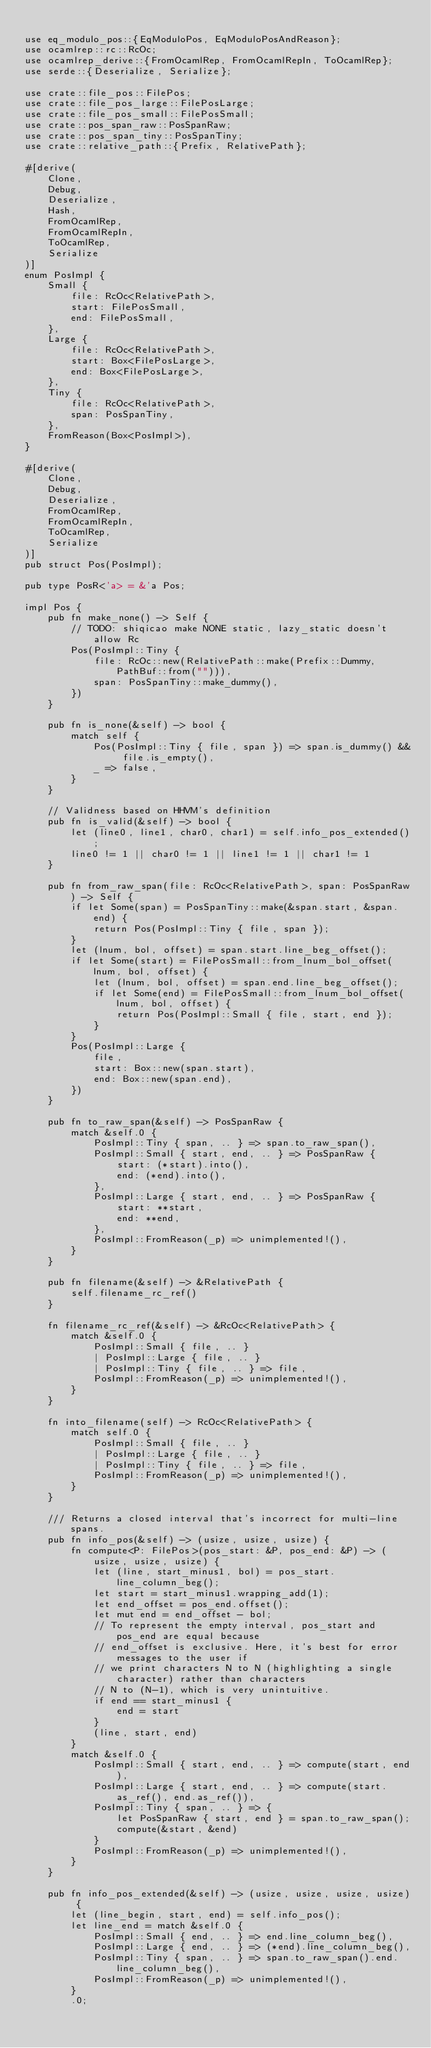<code> <loc_0><loc_0><loc_500><loc_500><_Rust_>
use eq_modulo_pos::{EqModuloPos, EqModuloPosAndReason};
use ocamlrep::rc::RcOc;
use ocamlrep_derive::{FromOcamlRep, FromOcamlRepIn, ToOcamlRep};
use serde::{Deserialize, Serialize};

use crate::file_pos::FilePos;
use crate::file_pos_large::FilePosLarge;
use crate::file_pos_small::FilePosSmall;
use crate::pos_span_raw::PosSpanRaw;
use crate::pos_span_tiny::PosSpanTiny;
use crate::relative_path::{Prefix, RelativePath};

#[derive(
    Clone,
    Debug,
    Deserialize,
    Hash,
    FromOcamlRep,
    FromOcamlRepIn,
    ToOcamlRep,
    Serialize
)]
enum PosImpl {
    Small {
        file: RcOc<RelativePath>,
        start: FilePosSmall,
        end: FilePosSmall,
    },
    Large {
        file: RcOc<RelativePath>,
        start: Box<FilePosLarge>,
        end: Box<FilePosLarge>,
    },
    Tiny {
        file: RcOc<RelativePath>,
        span: PosSpanTiny,
    },
    FromReason(Box<PosImpl>),
}

#[derive(
    Clone,
    Debug,
    Deserialize,
    FromOcamlRep,
    FromOcamlRepIn,
    ToOcamlRep,
    Serialize
)]
pub struct Pos(PosImpl);

pub type PosR<'a> = &'a Pos;

impl Pos {
    pub fn make_none() -> Self {
        // TODO: shiqicao make NONE static, lazy_static doesn't allow Rc
        Pos(PosImpl::Tiny {
            file: RcOc::new(RelativePath::make(Prefix::Dummy, PathBuf::from(""))),
            span: PosSpanTiny::make_dummy(),
        })
    }

    pub fn is_none(&self) -> bool {
        match self {
            Pos(PosImpl::Tiny { file, span }) => span.is_dummy() && file.is_empty(),
            _ => false,
        }
    }

    // Validness based on HHVM's definition
    pub fn is_valid(&self) -> bool {
        let (line0, line1, char0, char1) = self.info_pos_extended();
        line0 != 1 || char0 != 1 || line1 != 1 || char1 != 1
    }

    pub fn from_raw_span(file: RcOc<RelativePath>, span: PosSpanRaw) -> Self {
        if let Some(span) = PosSpanTiny::make(&span.start, &span.end) {
            return Pos(PosImpl::Tiny { file, span });
        }
        let (lnum, bol, offset) = span.start.line_beg_offset();
        if let Some(start) = FilePosSmall::from_lnum_bol_offset(lnum, bol, offset) {
            let (lnum, bol, offset) = span.end.line_beg_offset();
            if let Some(end) = FilePosSmall::from_lnum_bol_offset(lnum, bol, offset) {
                return Pos(PosImpl::Small { file, start, end });
            }
        }
        Pos(PosImpl::Large {
            file,
            start: Box::new(span.start),
            end: Box::new(span.end),
        })
    }

    pub fn to_raw_span(&self) -> PosSpanRaw {
        match &self.0 {
            PosImpl::Tiny { span, .. } => span.to_raw_span(),
            PosImpl::Small { start, end, .. } => PosSpanRaw {
                start: (*start).into(),
                end: (*end).into(),
            },
            PosImpl::Large { start, end, .. } => PosSpanRaw {
                start: **start,
                end: **end,
            },
            PosImpl::FromReason(_p) => unimplemented!(),
        }
    }

    pub fn filename(&self) -> &RelativePath {
        self.filename_rc_ref()
    }

    fn filename_rc_ref(&self) -> &RcOc<RelativePath> {
        match &self.0 {
            PosImpl::Small { file, .. }
            | PosImpl::Large { file, .. }
            | PosImpl::Tiny { file, .. } => file,
            PosImpl::FromReason(_p) => unimplemented!(),
        }
    }

    fn into_filename(self) -> RcOc<RelativePath> {
        match self.0 {
            PosImpl::Small { file, .. }
            | PosImpl::Large { file, .. }
            | PosImpl::Tiny { file, .. } => file,
            PosImpl::FromReason(_p) => unimplemented!(),
        }
    }

    /// Returns a closed interval that's incorrect for multi-line spans.
    pub fn info_pos(&self) -> (usize, usize, usize) {
        fn compute<P: FilePos>(pos_start: &P, pos_end: &P) -> (usize, usize, usize) {
            let (line, start_minus1, bol) = pos_start.line_column_beg();
            let start = start_minus1.wrapping_add(1);
            let end_offset = pos_end.offset();
            let mut end = end_offset - bol;
            // To represent the empty interval, pos_start and pos_end are equal because
            // end_offset is exclusive. Here, it's best for error messages to the user if
            // we print characters N to N (highlighting a single character) rather than characters
            // N to (N-1), which is very unintuitive.
            if end == start_minus1 {
                end = start
            }
            (line, start, end)
        }
        match &self.0 {
            PosImpl::Small { start, end, .. } => compute(start, end),
            PosImpl::Large { start, end, .. } => compute(start.as_ref(), end.as_ref()),
            PosImpl::Tiny { span, .. } => {
                let PosSpanRaw { start, end } = span.to_raw_span();
                compute(&start, &end)
            }
            PosImpl::FromReason(_p) => unimplemented!(),
        }
    }

    pub fn info_pos_extended(&self) -> (usize, usize, usize, usize) {
        let (line_begin, start, end) = self.info_pos();
        let line_end = match &self.0 {
            PosImpl::Small { end, .. } => end.line_column_beg(),
            PosImpl::Large { end, .. } => (*end).line_column_beg(),
            PosImpl::Tiny { span, .. } => span.to_raw_span().end.line_column_beg(),
            PosImpl::FromReason(_p) => unimplemented!(),
        }
        .0;</code> 